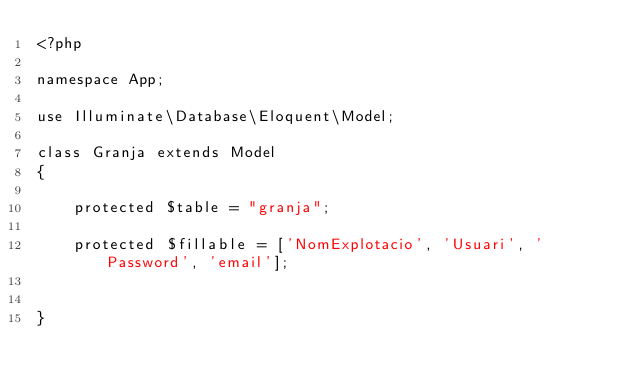<code> <loc_0><loc_0><loc_500><loc_500><_PHP_><?php

namespace App;

use Illuminate\Database\Eloquent\Model;

class Granja extends Model
{
    
    protected $table = "granja";
    
    protected $fillable = ['NomExplotacio', 'Usuari', 'Password', 'email'];
    
    
}
</code> 